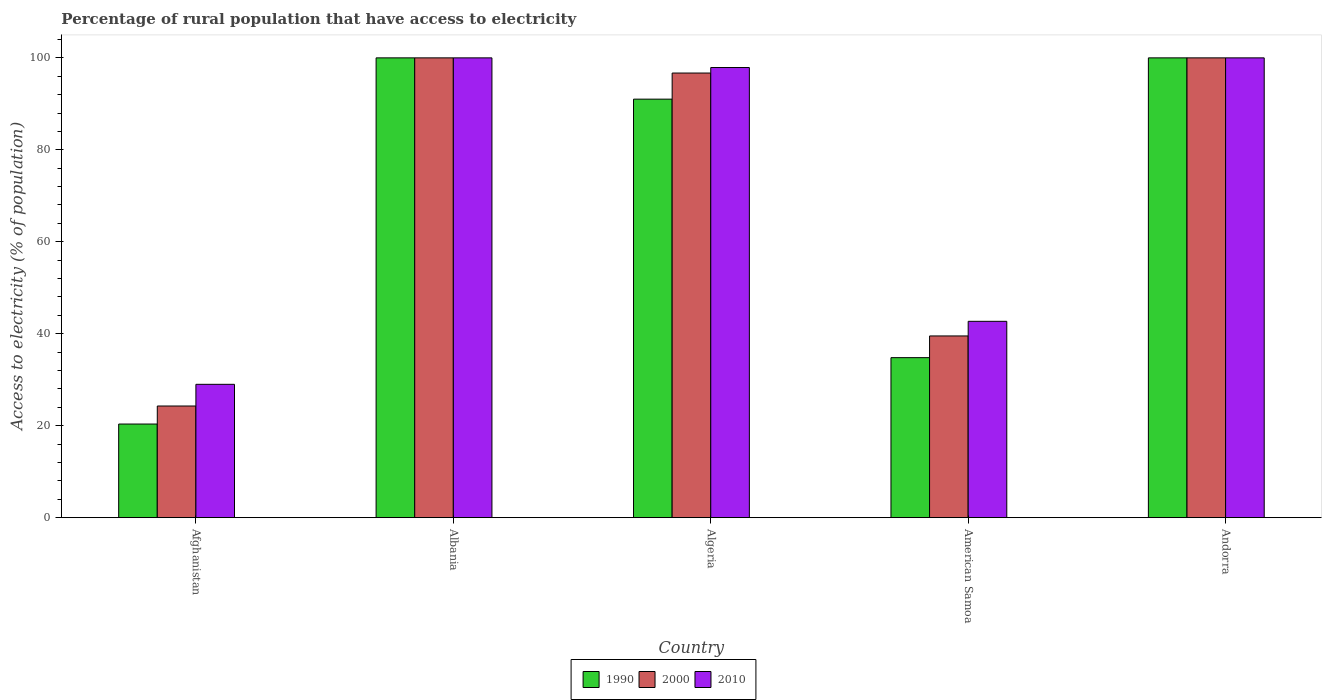How many groups of bars are there?
Your answer should be very brief. 5. Are the number of bars on each tick of the X-axis equal?
Ensure brevity in your answer.  Yes. How many bars are there on the 2nd tick from the right?
Offer a terse response. 3. What is the label of the 3rd group of bars from the left?
Offer a very short reply. Algeria. In how many cases, is the number of bars for a given country not equal to the number of legend labels?
Your response must be concise. 0. What is the percentage of rural population that have access to electricity in 2000 in American Samoa?
Your response must be concise. 39.52. Across all countries, what is the minimum percentage of rural population that have access to electricity in 1990?
Offer a terse response. 20.36. In which country was the percentage of rural population that have access to electricity in 2010 maximum?
Your answer should be compact. Albania. In which country was the percentage of rural population that have access to electricity in 1990 minimum?
Give a very brief answer. Afghanistan. What is the total percentage of rural population that have access to electricity in 2000 in the graph?
Provide a short and direct response. 360.5. What is the difference between the percentage of rural population that have access to electricity in 2000 in Albania and that in Algeria?
Offer a very short reply. 3.3. What is the difference between the percentage of rural population that have access to electricity in 2010 in Andorra and the percentage of rural population that have access to electricity in 2000 in Afghanistan?
Ensure brevity in your answer.  75.72. What is the average percentage of rural population that have access to electricity in 2000 per country?
Provide a succinct answer. 72.1. What is the difference between the percentage of rural population that have access to electricity of/in 2000 and percentage of rural population that have access to electricity of/in 1990 in American Samoa?
Your response must be concise. 4.72. What is the ratio of the percentage of rural population that have access to electricity in 1990 in Albania to that in Andorra?
Ensure brevity in your answer.  1. Is the percentage of rural population that have access to electricity in 1990 in Afghanistan less than that in Algeria?
Keep it short and to the point. Yes. What is the difference between the highest and the second highest percentage of rural population that have access to electricity in 2010?
Offer a very short reply. -2.1. What is the difference between the highest and the lowest percentage of rural population that have access to electricity in 1990?
Keep it short and to the point. 79.64. Is the sum of the percentage of rural population that have access to electricity in 1990 in Afghanistan and Andorra greater than the maximum percentage of rural population that have access to electricity in 2010 across all countries?
Offer a very short reply. Yes. What does the 1st bar from the left in Algeria represents?
Give a very brief answer. 1990. What does the 1st bar from the right in Algeria represents?
Make the answer very short. 2010. Does the graph contain any zero values?
Your response must be concise. No. Does the graph contain grids?
Make the answer very short. No. Where does the legend appear in the graph?
Provide a succinct answer. Bottom center. How many legend labels are there?
Provide a succinct answer. 3. What is the title of the graph?
Provide a succinct answer. Percentage of rural population that have access to electricity. Does "2012" appear as one of the legend labels in the graph?
Offer a very short reply. No. What is the label or title of the X-axis?
Your answer should be very brief. Country. What is the label or title of the Y-axis?
Provide a succinct answer. Access to electricity (% of population). What is the Access to electricity (% of population) of 1990 in Afghanistan?
Make the answer very short. 20.36. What is the Access to electricity (% of population) in 2000 in Afghanistan?
Offer a very short reply. 24.28. What is the Access to electricity (% of population) of 2010 in Albania?
Ensure brevity in your answer.  100. What is the Access to electricity (% of population) of 1990 in Algeria?
Provide a short and direct response. 91.02. What is the Access to electricity (% of population) of 2000 in Algeria?
Provide a succinct answer. 96.7. What is the Access to electricity (% of population) in 2010 in Algeria?
Your answer should be compact. 97.9. What is the Access to electricity (% of population) of 1990 in American Samoa?
Your answer should be compact. 34.8. What is the Access to electricity (% of population) in 2000 in American Samoa?
Ensure brevity in your answer.  39.52. What is the Access to electricity (% of population) in 2010 in American Samoa?
Your answer should be compact. 42.7. What is the Access to electricity (% of population) of 2000 in Andorra?
Offer a terse response. 100. Across all countries, what is the maximum Access to electricity (% of population) of 1990?
Provide a succinct answer. 100. Across all countries, what is the maximum Access to electricity (% of population) in 2010?
Provide a short and direct response. 100. Across all countries, what is the minimum Access to electricity (% of population) in 1990?
Your answer should be very brief. 20.36. Across all countries, what is the minimum Access to electricity (% of population) in 2000?
Provide a succinct answer. 24.28. What is the total Access to electricity (% of population) in 1990 in the graph?
Ensure brevity in your answer.  346.18. What is the total Access to electricity (% of population) of 2000 in the graph?
Your answer should be very brief. 360.5. What is the total Access to electricity (% of population) of 2010 in the graph?
Offer a very short reply. 369.6. What is the difference between the Access to electricity (% of population) of 1990 in Afghanistan and that in Albania?
Offer a terse response. -79.64. What is the difference between the Access to electricity (% of population) in 2000 in Afghanistan and that in Albania?
Provide a short and direct response. -75.72. What is the difference between the Access to electricity (% of population) in 2010 in Afghanistan and that in Albania?
Ensure brevity in your answer.  -71. What is the difference between the Access to electricity (% of population) of 1990 in Afghanistan and that in Algeria?
Offer a terse response. -70.66. What is the difference between the Access to electricity (% of population) in 2000 in Afghanistan and that in Algeria?
Your response must be concise. -72.42. What is the difference between the Access to electricity (% of population) in 2010 in Afghanistan and that in Algeria?
Your answer should be very brief. -68.9. What is the difference between the Access to electricity (% of population) of 1990 in Afghanistan and that in American Samoa?
Provide a succinct answer. -14.44. What is the difference between the Access to electricity (% of population) in 2000 in Afghanistan and that in American Samoa?
Make the answer very short. -15.24. What is the difference between the Access to electricity (% of population) in 2010 in Afghanistan and that in American Samoa?
Your answer should be compact. -13.7. What is the difference between the Access to electricity (% of population) of 1990 in Afghanistan and that in Andorra?
Your answer should be very brief. -79.64. What is the difference between the Access to electricity (% of population) of 2000 in Afghanistan and that in Andorra?
Ensure brevity in your answer.  -75.72. What is the difference between the Access to electricity (% of population) of 2010 in Afghanistan and that in Andorra?
Provide a succinct answer. -71. What is the difference between the Access to electricity (% of population) in 1990 in Albania and that in Algeria?
Provide a short and direct response. 8.98. What is the difference between the Access to electricity (% of population) in 2010 in Albania and that in Algeria?
Offer a terse response. 2.1. What is the difference between the Access to electricity (% of population) in 1990 in Albania and that in American Samoa?
Offer a very short reply. 65.2. What is the difference between the Access to electricity (% of population) of 2000 in Albania and that in American Samoa?
Your answer should be very brief. 60.48. What is the difference between the Access to electricity (% of population) in 2010 in Albania and that in American Samoa?
Ensure brevity in your answer.  57.3. What is the difference between the Access to electricity (% of population) in 1990 in Albania and that in Andorra?
Your response must be concise. 0. What is the difference between the Access to electricity (% of population) in 2000 in Albania and that in Andorra?
Provide a succinct answer. 0. What is the difference between the Access to electricity (% of population) of 1990 in Algeria and that in American Samoa?
Make the answer very short. 56.22. What is the difference between the Access to electricity (% of population) of 2000 in Algeria and that in American Samoa?
Your answer should be compact. 57.18. What is the difference between the Access to electricity (% of population) in 2010 in Algeria and that in American Samoa?
Offer a very short reply. 55.2. What is the difference between the Access to electricity (% of population) of 1990 in Algeria and that in Andorra?
Give a very brief answer. -8.98. What is the difference between the Access to electricity (% of population) of 2000 in Algeria and that in Andorra?
Your answer should be compact. -3.3. What is the difference between the Access to electricity (% of population) in 1990 in American Samoa and that in Andorra?
Keep it short and to the point. -65.2. What is the difference between the Access to electricity (% of population) of 2000 in American Samoa and that in Andorra?
Keep it short and to the point. -60.48. What is the difference between the Access to electricity (% of population) of 2010 in American Samoa and that in Andorra?
Make the answer very short. -57.3. What is the difference between the Access to electricity (% of population) of 1990 in Afghanistan and the Access to electricity (% of population) of 2000 in Albania?
Make the answer very short. -79.64. What is the difference between the Access to electricity (% of population) of 1990 in Afghanistan and the Access to electricity (% of population) of 2010 in Albania?
Offer a very short reply. -79.64. What is the difference between the Access to electricity (% of population) of 2000 in Afghanistan and the Access to electricity (% of population) of 2010 in Albania?
Offer a terse response. -75.72. What is the difference between the Access to electricity (% of population) in 1990 in Afghanistan and the Access to electricity (% of population) in 2000 in Algeria?
Your response must be concise. -76.34. What is the difference between the Access to electricity (% of population) in 1990 in Afghanistan and the Access to electricity (% of population) in 2010 in Algeria?
Give a very brief answer. -77.54. What is the difference between the Access to electricity (% of population) in 2000 in Afghanistan and the Access to electricity (% of population) in 2010 in Algeria?
Make the answer very short. -73.62. What is the difference between the Access to electricity (% of population) of 1990 in Afghanistan and the Access to electricity (% of population) of 2000 in American Samoa?
Make the answer very short. -19.16. What is the difference between the Access to electricity (% of population) in 1990 in Afghanistan and the Access to electricity (% of population) in 2010 in American Samoa?
Keep it short and to the point. -22.34. What is the difference between the Access to electricity (% of population) of 2000 in Afghanistan and the Access to electricity (% of population) of 2010 in American Samoa?
Make the answer very short. -18.42. What is the difference between the Access to electricity (% of population) in 1990 in Afghanistan and the Access to electricity (% of population) in 2000 in Andorra?
Provide a short and direct response. -79.64. What is the difference between the Access to electricity (% of population) in 1990 in Afghanistan and the Access to electricity (% of population) in 2010 in Andorra?
Your response must be concise. -79.64. What is the difference between the Access to electricity (% of population) of 2000 in Afghanistan and the Access to electricity (% of population) of 2010 in Andorra?
Keep it short and to the point. -75.72. What is the difference between the Access to electricity (% of population) of 1990 in Albania and the Access to electricity (% of population) of 2000 in Algeria?
Ensure brevity in your answer.  3.3. What is the difference between the Access to electricity (% of population) in 2000 in Albania and the Access to electricity (% of population) in 2010 in Algeria?
Offer a terse response. 2.1. What is the difference between the Access to electricity (% of population) of 1990 in Albania and the Access to electricity (% of population) of 2000 in American Samoa?
Offer a very short reply. 60.48. What is the difference between the Access to electricity (% of population) in 1990 in Albania and the Access to electricity (% of population) in 2010 in American Samoa?
Keep it short and to the point. 57.3. What is the difference between the Access to electricity (% of population) in 2000 in Albania and the Access to electricity (% of population) in 2010 in American Samoa?
Make the answer very short. 57.3. What is the difference between the Access to electricity (% of population) in 1990 in Algeria and the Access to electricity (% of population) in 2000 in American Samoa?
Ensure brevity in your answer.  51.5. What is the difference between the Access to electricity (% of population) of 1990 in Algeria and the Access to electricity (% of population) of 2010 in American Samoa?
Offer a very short reply. 48.32. What is the difference between the Access to electricity (% of population) of 1990 in Algeria and the Access to electricity (% of population) of 2000 in Andorra?
Offer a very short reply. -8.98. What is the difference between the Access to electricity (% of population) in 1990 in Algeria and the Access to electricity (% of population) in 2010 in Andorra?
Offer a terse response. -8.98. What is the difference between the Access to electricity (% of population) of 1990 in American Samoa and the Access to electricity (% of population) of 2000 in Andorra?
Offer a very short reply. -65.2. What is the difference between the Access to electricity (% of population) in 1990 in American Samoa and the Access to electricity (% of population) in 2010 in Andorra?
Your answer should be compact. -65.2. What is the difference between the Access to electricity (% of population) of 2000 in American Samoa and the Access to electricity (% of population) of 2010 in Andorra?
Give a very brief answer. -60.48. What is the average Access to electricity (% of population) of 1990 per country?
Provide a short and direct response. 69.24. What is the average Access to electricity (% of population) in 2000 per country?
Keep it short and to the point. 72.1. What is the average Access to electricity (% of population) in 2010 per country?
Ensure brevity in your answer.  73.92. What is the difference between the Access to electricity (% of population) in 1990 and Access to electricity (% of population) in 2000 in Afghanistan?
Offer a very short reply. -3.92. What is the difference between the Access to electricity (% of population) of 1990 and Access to electricity (% of population) of 2010 in Afghanistan?
Offer a very short reply. -8.64. What is the difference between the Access to electricity (% of population) of 2000 and Access to electricity (% of population) of 2010 in Afghanistan?
Your response must be concise. -4.72. What is the difference between the Access to electricity (% of population) of 1990 and Access to electricity (% of population) of 2010 in Albania?
Offer a very short reply. 0. What is the difference between the Access to electricity (% of population) of 1990 and Access to electricity (% of population) of 2000 in Algeria?
Give a very brief answer. -5.68. What is the difference between the Access to electricity (% of population) in 1990 and Access to electricity (% of population) in 2010 in Algeria?
Keep it short and to the point. -6.88. What is the difference between the Access to electricity (% of population) of 1990 and Access to electricity (% of population) of 2000 in American Samoa?
Provide a succinct answer. -4.72. What is the difference between the Access to electricity (% of population) in 1990 and Access to electricity (% of population) in 2010 in American Samoa?
Provide a succinct answer. -7.9. What is the difference between the Access to electricity (% of population) in 2000 and Access to electricity (% of population) in 2010 in American Samoa?
Offer a very short reply. -3.18. What is the difference between the Access to electricity (% of population) of 1990 and Access to electricity (% of population) of 2000 in Andorra?
Your answer should be compact. 0. What is the ratio of the Access to electricity (% of population) of 1990 in Afghanistan to that in Albania?
Provide a short and direct response. 0.2. What is the ratio of the Access to electricity (% of population) of 2000 in Afghanistan to that in Albania?
Ensure brevity in your answer.  0.24. What is the ratio of the Access to electricity (% of population) of 2010 in Afghanistan to that in Albania?
Ensure brevity in your answer.  0.29. What is the ratio of the Access to electricity (% of population) of 1990 in Afghanistan to that in Algeria?
Offer a very short reply. 0.22. What is the ratio of the Access to electricity (% of population) in 2000 in Afghanistan to that in Algeria?
Provide a succinct answer. 0.25. What is the ratio of the Access to electricity (% of population) in 2010 in Afghanistan to that in Algeria?
Your response must be concise. 0.3. What is the ratio of the Access to electricity (% of population) of 1990 in Afghanistan to that in American Samoa?
Provide a short and direct response. 0.59. What is the ratio of the Access to electricity (% of population) of 2000 in Afghanistan to that in American Samoa?
Provide a succinct answer. 0.61. What is the ratio of the Access to electricity (% of population) of 2010 in Afghanistan to that in American Samoa?
Provide a succinct answer. 0.68. What is the ratio of the Access to electricity (% of population) in 1990 in Afghanistan to that in Andorra?
Offer a terse response. 0.2. What is the ratio of the Access to electricity (% of population) in 2000 in Afghanistan to that in Andorra?
Offer a terse response. 0.24. What is the ratio of the Access to electricity (% of population) in 2010 in Afghanistan to that in Andorra?
Your answer should be very brief. 0.29. What is the ratio of the Access to electricity (% of population) of 1990 in Albania to that in Algeria?
Give a very brief answer. 1.1. What is the ratio of the Access to electricity (% of population) of 2000 in Albania to that in Algeria?
Your answer should be very brief. 1.03. What is the ratio of the Access to electricity (% of population) in 2010 in Albania to that in Algeria?
Offer a terse response. 1.02. What is the ratio of the Access to electricity (% of population) in 1990 in Albania to that in American Samoa?
Your answer should be very brief. 2.87. What is the ratio of the Access to electricity (% of population) of 2000 in Albania to that in American Samoa?
Your answer should be compact. 2.53. What is the ratio of the Access to electricity (% of population) in 2010 in Albania to that in American Samoa?
Provide a short and direct response. 2.34. What is the ratio of the Access to electricity (% of population) of 1990 in Albania to that in Andorra?
Your answer should be compact. 1. What is the ratio of the Access to electricity (% of population) in 2000 in Albania to that in Andorra?
Your response must be concise. 1. What is the ratio of the Access to electricity (% of population) in 2010 in Albania to that in Andorra?
Provide a short and direct response. 1. What is the ratio of the Access to electricity (% of population) of 1990 in Algeria to that in American Samoa?
Your answer should be very brief. 2.62. What is the ratio of the Access to electricity (% of population) in 2000 in Algeria to that in American Samoa?
Provide a short and direct response. 2.45. What is the ratio of the Access to electricity (% of population) in 2010 in Algeria to that in American Samoa?
Keep it short and to the point. 2.29. What is the ratio of the Access to electricity (% of population) of 1990 in Algeria to that in Andorra?
Make the answer very short. 0.91. What is the ratio of the Access to electricity (% of population) in 2000 in Algeria to that in Andorra?
Provide a succinct answer. 0.97. What is the ratio of the Access to electricity (% of population) in 1990 in American Samoa to that in Andorra?
Keep it short and to the point. 0.35. What is the ratio of the Access to electricity (% of population) in 2000 in American Samoa to that in Andorra?
Provide a succinct answer. 0.4. What is the ratio of the Access to electricity (% of population) in 2010 in American Samoa to that in Andorra?
Offer a terse response. 0.43. What is the difference between the highest and the second highest Access to electricity (% of population) of 2000?
Give a very brief answer. 0. What is the difference between the highest and the lowest Access to electricity (% of population) of 1990?
Your answer should be very brief. 79.64. What is the difference between the highest and the lowest Access to electricity (% of population) in 2000?
Your answer should be very brief. 75.72. 